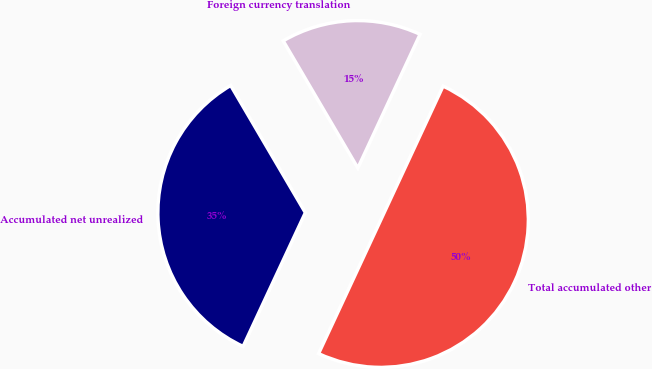<chart> <loc_0><loc_0><loc_500><loc_500><pie_chart><fcel>Foreign currency translation<fcel>Accumulated net unrealized<fcel>Total accumulated other<nl><fcel>15.38%<fcel>34.62%<fcel>50.0%<nl></chart> 